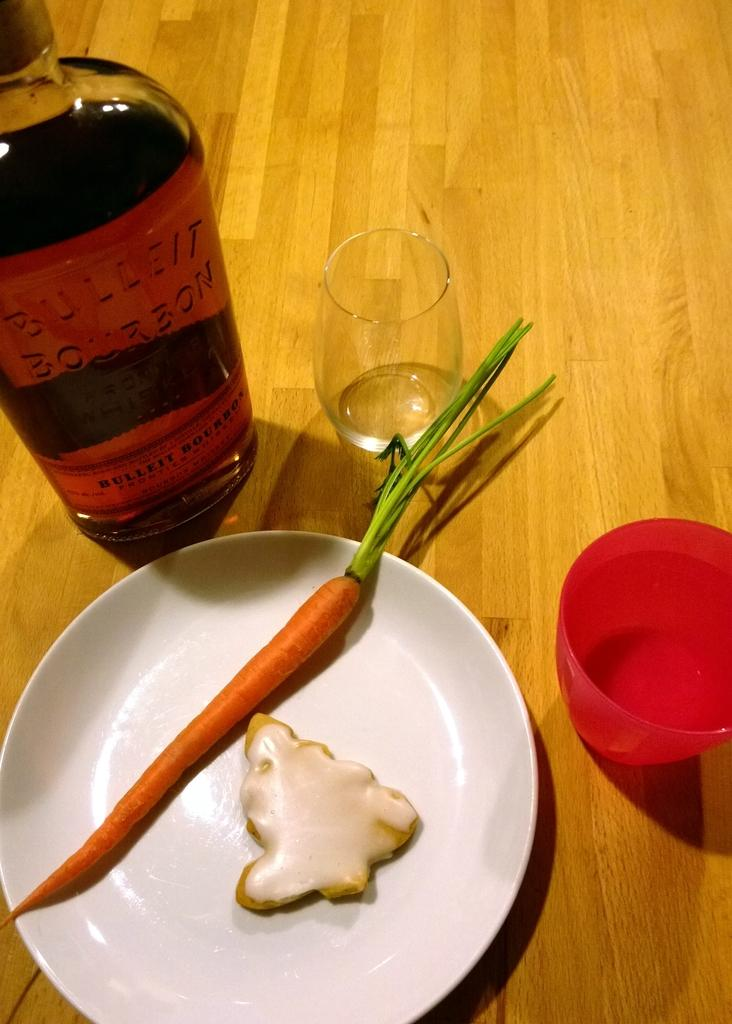Provide a one-sentence caption for the provided image. A bottle of bulleit bourbon along with a single carrot and cookie on a plate. 